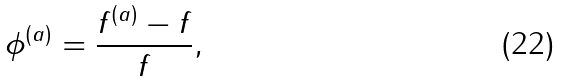Convert formula to latex. <formula><loc_0><loc_0><loc_500><loc_500>\phi ^ { \left ( a \right ) } = \frac { f ^ { \left ( a \right ) } - f } { f } ,</formula> 